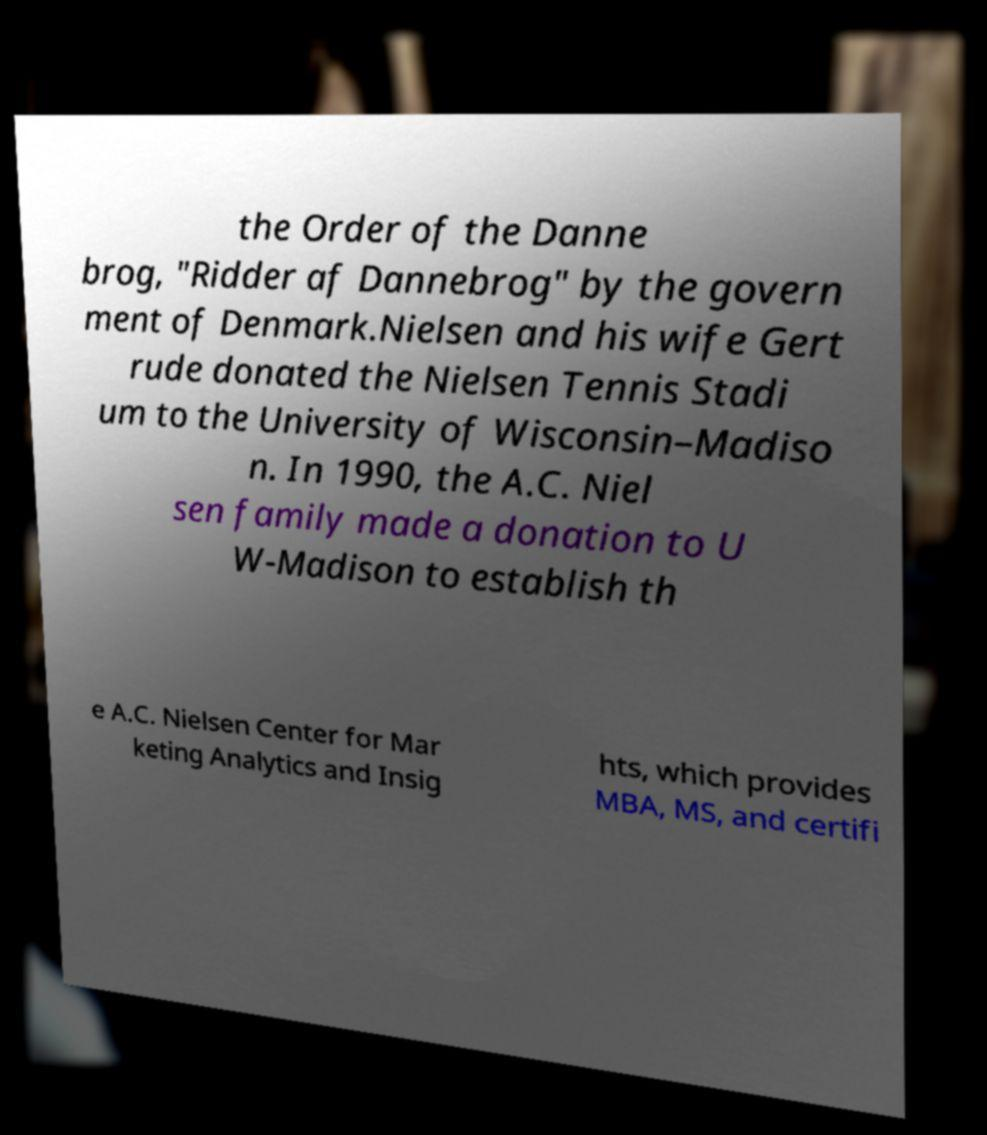Could you extract and type out the text from this image? the Order of the Danne brog, "Ridder af Dannebrog" by the govern ment of Denmark.Nielsen and his wife Gert rude donated the Nielsen Tennis Stadi um to the University of Wisconsin–Madiso n. In 1990, the A.C. Niel sen family made a donation to U W-Madison to establish th e A.C. Nielsen Center for Mar keting Analytics and Insig hts, which provides MBA, MS, and certifi 